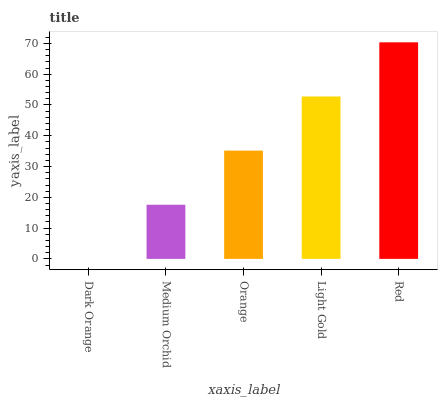Is Dark Orange the minimum?
Answer yes or no. Yes. Is Red the maximum?
Answer yes or no. Yes. Is Medium Orchid the minimum?
Answer yes or no. No. Is Medium Orchid the maximum?
Answer yes or no. No. Is Medium Orchid greater than Dark Orange?
Answer yes or no. Yes. Is Dark Orange less than Medium Orchid?
Answer yes or no. Yes. Is Dark Orange greater than Medium Orchid?
Answer yes or no. No. Is Medium Orchid less than Dark Orange?
Answer yes or no. No. Is Orange the high median?
Answer yes or no. Yes. Is Orange the low median?
Answer yes or no. Yes. Is Red the high median?
Answer yes or no. No. Is Red the low median?
Answer yes or no. No. 